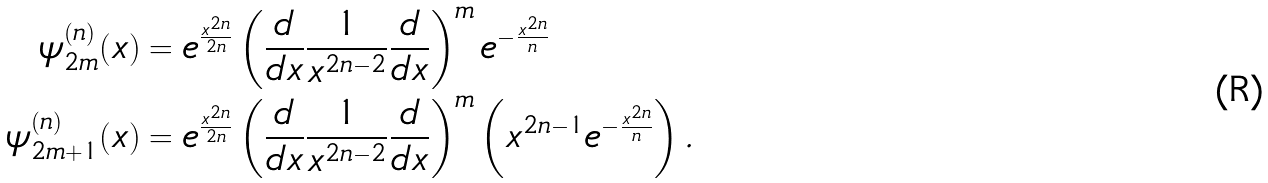<formula> <loc_0><loc_0><loc_500><loc_500>\psi _ { 2 m } ^ { ( n ) } ( x ) & = e ^ { \frac { x ^ { 2 n } } { 2 n } } \left ( \frac { d } { d x } \frac { 1 } { x ^ { 2 n - 2 } } \frac { d } { d x } \right ) ^ { m } e ^ { - \frac { x ^ { 2 n } } { n } } \\ \psi _ { 2 m + 1 } ^ { ( n ) } ( x ) & = e ^ { \frac { x ^ { 2 n } } { 2 n } } \left ( \frac { d } { d x } \frac { 1 } { x ^ { 2 n - 2 } } \frac { d } { d x } \right ) ^ { m } \left ( x ^ { 2 n - 1 } e ^ { - \frac { x ^ { 2 n } } { n } } \right ) .</formula> 